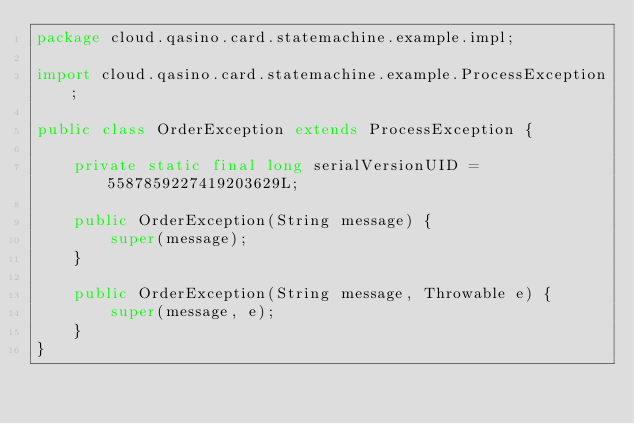Convert code to text. <code><loc_0><loc_0><loc_500><loc_500><_Java_>package cloud.qasino.card.statemachine.example.impl;

import cloud.qasino.card.statemachine.example.ProcessException;

public class OrderException extends ProcessException {

    private static final long serialVersionUID = 5587859227419203629L;
    
    public OrderException(String message) {
        super(message);
    }

    public OrderException(String message, Throwable e) {
        super(message, e);
    }
}</code> 